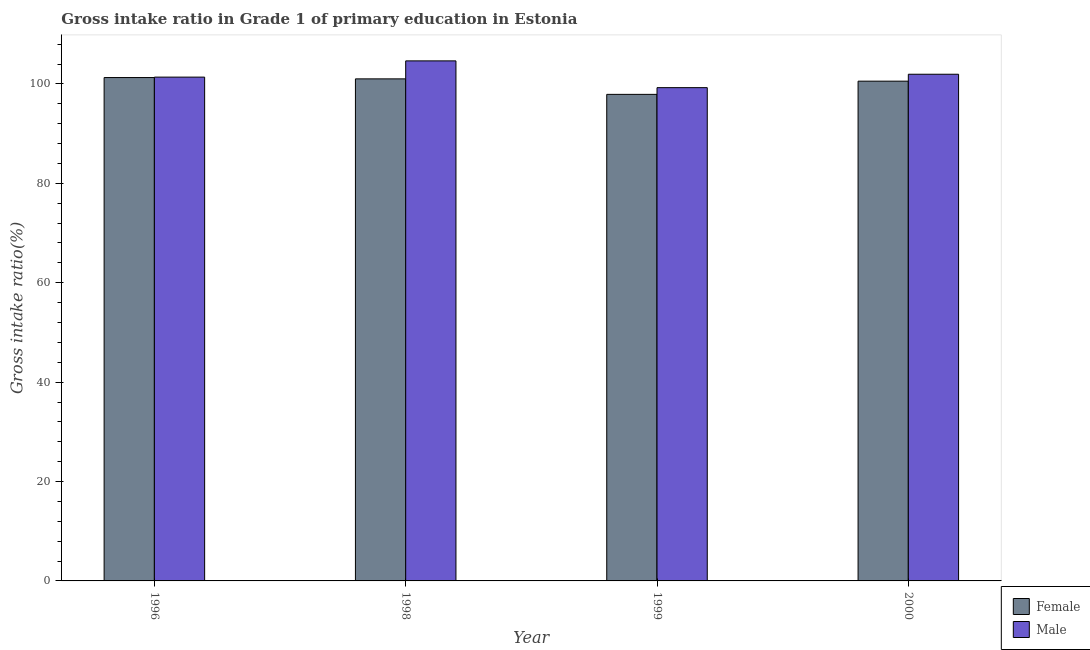How many different coloured bars are there?
Ensure brevity in your answer.  2. How many groups of bars are there?
Make the answer very short. 4. Are the number of bars per tick equal to the number of legend labels?
Keep it short and to the point. Yes. Are the number of bars on each tick of the X-axis equal?
Your answer should be compact. Yes. How many bars are there on the 4th tick from the right?
Keep it short and to the point. 2. What is the label of the 4th group of bars from the left?
Provide a succinct answer. 2000. In how many cases, is the number of bars for a given year not equal to the number of legend labels?
Your answer should be compact. 0. What is the gross intake ratio(male) in 2000?
Your answer should be compact. 101.95. Across all years, what is the maximum gross intake ratio(female)?
Give a very brief answer. 101.28. Across all years, what is the minimum gross intake ratio(female)?
Keep it short and to the point. 97.9. What is the total gross intake ratio(male) in the graph?
Offer a terse response. 407.2. What is the difference between the gross intake ratio(female) in 1999 and that in 2000?
Provide a succinct answer. -2.65. What is the difference between the gross intake ratio(female) in 1996 and the gross intake ratio(male) in 2000?
Your answer should be compact. 0.73. What is the average gross intake ratio(female) per year?
Provide a succinct answer. 100.19. In how many years, is the gross intake ratio(female) greater than 88 %?
Keep it short and to the point. 4. What is the ratio of the gross intake ratio(male) in 1998 to that in 2000?
Your answer should be very brief. 1.03. Is the gross intake ratio(female) in 1996 less than that in 2000?
Make the answer very short. No. Is the difference between the gross intake ratio(female) in 1998 and 2000 greater than the difference between the gross intake ratio(male) in 1998 and 2000?
Keep it short and to the point. No. What is the difference between the highest and the second highest gross intake ratio(female)?
Provide a short and direct response. 0.27. What is the difference between the highest and the lowest gross intake ratio(female)?
Offer a very short reply. 3.38. Is the sum of the gross intake ratio(male) in 1999 and 2000 greater than the maximum gross intake ratio(female) across all years?
Make the answer very short. Yes. What does the 1st bar from the right in 1996 represents?
Ensure brevity in your answer.  Male. Are all the bars in the graph horizontal?
Ensure brevity in your answer.  No. What is the difference between two consecutive major ticks on the Y-axis?
Your response must be concise. 20. Does the graph contain any zero values?
Make the answer very short. No. How many legend labels are there?
Your answer should be very brief. 2. How are the legend labels stacked?
Make the answer very short. Vertical. What is the title of the graph?
Offer a very short reply. Gross intake ratio in Grade 1 of primary education in Estonia. What is the label or title of the X-axis?
Provide a short and direct response. Year. What is the label or title of the Y-axis?
Provide a succinct answer. Gross intake ratio(%). What is the Gross intake ratio(%) of Female in 1996?
Your response must be concise. 101.28. What is the Gross intake ratio(%) in Male in 1996?
Offer a terse response. 101.37. What is the Gross intake ratio(%) of Female in 1998?
Provide a short and direct response. 101.02. What is the Gross intake ratio(%) of Male in 1998?
Provide a short and direct response. 104.64. What is the Gross intake ratio(%) of Female in 1999?
Offer a very short reply. 97.9. What is the Gross intake ratio(%) in Male in 1999?
Keep it short and to the point. 99.25. What is the Gross intake ratio(%) in Female in 2000?
Keep it short and to the point. 100.55. What is the Gross intake ratio(%) in Male in 2000?
Keep it short and to the point. 101.95. Across all years, what is the maximum Gross intake ratio(%) in Female?
Ensure brevity in your answer.  101.28. Across all years, what is the maximum Gross intake ratio(%) of Male?
Offer a terse response. 104.64. Across all years, what is the minimum Gross intake ratio(%) of Female?
Provide a succinct answer. 97.9. Across all years, what is the minimum Gross intake ratio(%) in Male?
Provide a short and direct response. 99.25. What is the total Gross intake ratio(%) in Female in the graph?
Your answer should be compact. 400.75. What is the total Gross intake ratio(%) of Male in the graph?
Your answer should be compact. 407.2. What is the difference between the Gross intake ratio(%) of Female in 1996 and that in 1998?
Provide a short and direct response. 0.27. What is the difference between the Gross intake ratio(%) of Male in 1996 and that in 1998?
Your response must be concise. -3.27. What is the difference between the Gross intake ratio(%) of Female in 1996 and that in 1999?
Give a very brief answer. 3.38. What is the difference between the Gross intake ratio(%) of Male in 1996 and that in 1999?
Your answer should be compact. 2.12. What is the difference between the Gross intake ratio(%) in Female in 1996 and that in 2000?
Make the answer very short. 0.73. What is the difference between the Gross intake ratio(%) in Male in 1996 and that in 2000?
Give a very brief answer. -0.58. What is the difference between the Gross intake ratio(%) of Female in 1998 and that in 1999?
Your response must be concise. 3.12. What is the difference between the Gross intake ratio(%) in Male in 1998 and that in 1999?
Offer a very short reply. 5.39. What is the difference between the Gross intake ratio(%) in Female in 1998 and that in 2000?
Your answer should be very brief. 0.46. What is the difference between the Gross intake ratio(%) in Male in 1998 and that in 2000?
Your answer should be compact. 2.69. What is the difference between the Gross intake ratio(%) of Female in 1999 and that in 2000?
Your answer should be compact. -2.65. What is the difference between the Gross intake ratio(%) in Male in 1999 and that in 2000?
Offer a very short reply. -2.7. What is the difference between the Gross intake ratio(%) of Female in 1996 and the Gross intake ratio(%) of Male in 1998?
Offer a terse response. -3.35. What is the difference between the Gross intake ratio(%) in Female in 1996 and the Gross intake ratio(%) in Male in 1999?
Offer a very short reply. 2.03. What is the difference between the Gross intake ratio(%) of Female in 1996 and the Gross intake ratio(%) of Male in 2000?
Keep it short and to the point. -0.67. What is the difference between the Gross intake ratio(%) in Female in 1998 and the Gross intake ratio(%) in Male in 1999?
Your response must be concise. 1.77. What is the difference between the Gross intake ratio(%) of Female in 1998 and the Gross intake ratio(%) of Male in 2000?
Your answer should be compact. -0.93. What is the difference between the Gross intake ratio(%) in Female in 1999 and the Gross intake ratio(%) in Male in 2000?
Offer a terse response. -4.05. What is the average Gross intake ratio(%) in Female per year?
Ensure brevity in your answer.  100.19. What is the average Gross intake ratio(%) in Male per year?
Keep it short and to the point. 101.8. In the year 1996, what is the difference between the Gross intake ratio(%) of Female and Gross intake ratio(%) of Male?
Offer a very short reply. -0.09. In the year 1998, what is the difference between the Gross intake ratio(%) in Female and Gross intake ratio(%) in Male?
Keep it short and to the point. -3.62. In the year 1999, what is the difference between the Gross intake ratio(%) of Female and Gross intake ratio(%) of Male?
Offer a terse response. -1.35. In the year 2000, what is the difference between the Gross intake ratio(%) of Female and Gross intake ratio(%) of Male?
Offer a very short reply. -1.39. What is the ratio of the Gross intake ratio(%) in Female in 1996 to that in 1998?
Your answer should be very brief. 1. What is the ratio of the Gross intake ratio(%) of Male in 1996 to that in 1998?
Your answer should be compact. 0.97. What is the ratio of the Gross intake ratio(%) of Female in 1996 to that in 1999?
Give a very brief answer. 1.03. What is the ratio of the Gross intake ratio(%) in Male in 1996 to that in 1999?
Your response must be concise. 1.02. What is the ratio of the Gross intake ratio(%) of Female in 1996 to that in 2000?
Your response must be concise. 1.01. What is the ratio of the Gross intake ratio(%) of Male in 1996 to that in 2000?
Offer a very short reply. 0.99. What is the ratio of the Gross intake ratio(%) of Female in 1998 to that in 1999?
Offer a very short reply. 1.03. What is the ratio of the Gross intake ratio(%) in Male in 1998 to that in 1999?
Provide a short and direct response. 1.05. What is the ratio of the Gross intake ratio(%) of Female in 1998 to that in 2000?
Keep it short and to the point. 1. What is the ratio of the Gross intake ratio(%) in Male in 1998 to that in 2000?
Provide a succinct answer. 1.03. What is the ratio of the Gross intake ratio(%) in Female in 1999 to that in 2000?
Give a very brief answer. 0.97. What is the ratio of the Gross intake ratio(%) in Male in 1999 to that in 2000?
Offer a very short reply. 0.97. What is the difference between the highest and the second highest Gross intake ratio(%) of Female?
Provide a short and direct response. 0.27. What is the difference between the highest and the second highest Gross intake ratio(%) of Male?
Give a very brief answer. 2.69. What is the difference between the highest and the lowest Gross intake ratio(%) of Female?
Keep it short and to the point. 3.38. What is the difference between the highest and the lowest Gross intake ratio(%) in Male?
Your response must be concise. 5.39. 